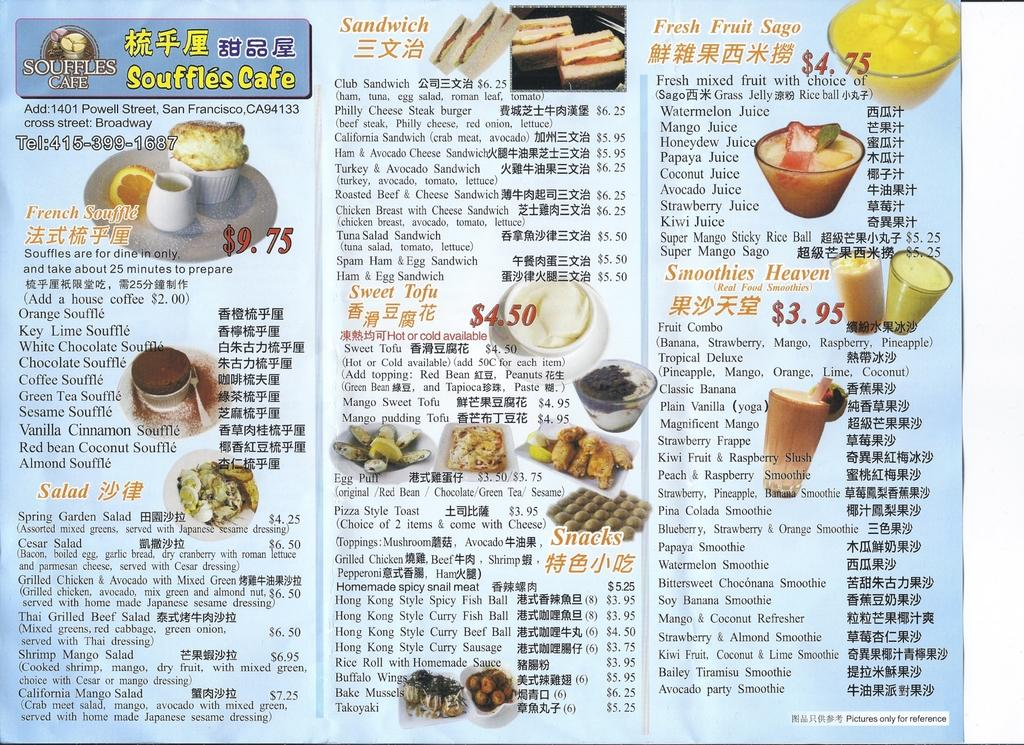What is the primary object in the image? There is a menu card in the image. What else can be seen in the image besides the menu card? There are glasses, plates, and a bowl with food items in the image. Can you describe the food items in the bowl? Unfortunately, the specific food items cannot be determined from the image. What type of belief is depicted on the menu card in the image? There is no belief depicted on the menu card in the image; it is a list of food items and possibly other information related to a restaurant or dining establishment. 